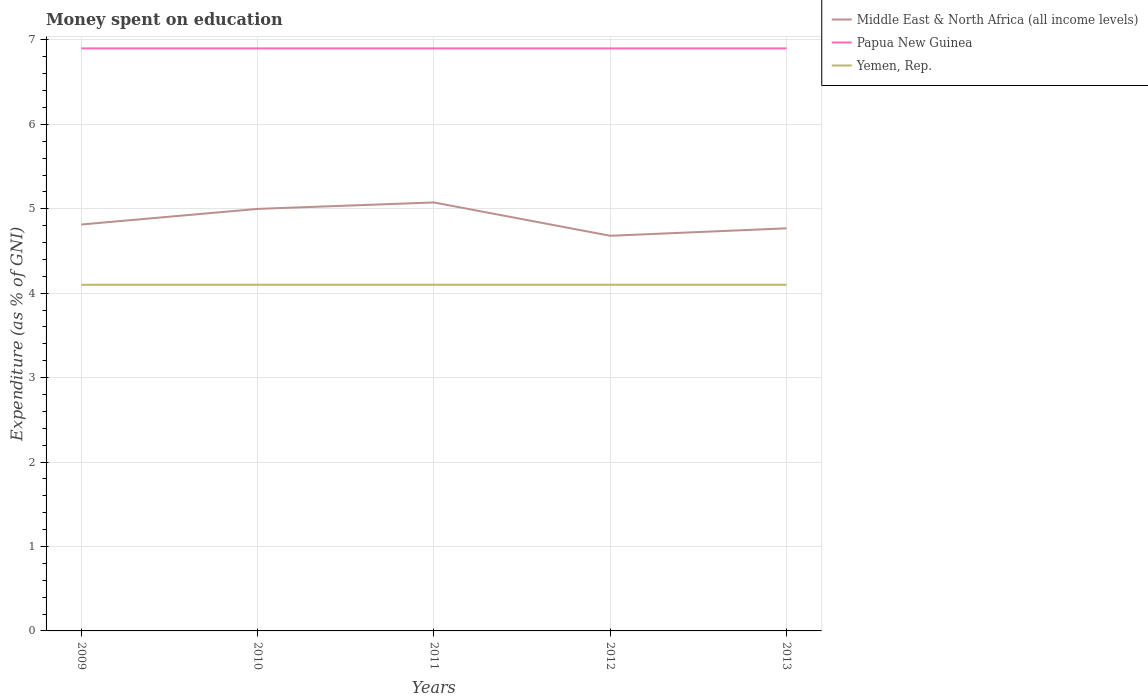How many different coloured lines are there?
Offer a very short reply. 3. In which year was the amount of money spent on education in Papua New Guinea maximum?
Offer a very short reply. 2009. What is the total amount of money spent on education in Papua New Guinea in the graph?
Keep it short and to the point. 0. What is the difference between the highest and the second highest amount of money spent on education in Middle East & North Africa (all income levels)?
Offer a very short reply. 0.39. What is the difference between the highest and the lowest amount of money spent on education in Papua New Guinea?
Offer a very short reply. 0. Is the amount of money spent on education in Middle East & North Africa (all income levels) strictly greater than the amount of money spent on education in Papua New Guinea over the years?
Offer a very short reply. Yes. How many years are there in the graph?
Offer a terse response. 5. What is the difference between two consecutive major ticks on the Y-axis?
Give a very brief answer. 1. Are the values on the major ticks of Y-axis written in scientific E-notation?
Give a very brief answer. No. Does the graph contain any zero values?
Your answer should be compact. No. Does the graph contain grids?
Ensure brevity in your answer.  Yes. Where does the legend appear in the graph?
Keep it short and to the point. Top right. What is the title of the graph?
Make the answer very short. Money spent on education. Does "San Marino" appear as one of the legend labels in the graph?
Offer a terse response. No. What is the label or title of the Y-axis?
Make the answer very short. Expenditure (as % of GNI). What is the Expenditure (as % of GNI) of Middle East & North Africa (all income levels) in 2009?
Give a very brief answer. 4.81. What is the Expenditure (as % of GNI) in Yemen, Rep. in 2009?
Keep it short and to the point. 4.1. What is the Expenditure (as % of GNI) in Middle East & North Africa (all income levels) in 2010?
Keep it short and to the point. 5. What is the Expenditure (as % of GNI) in Papua New Guinea in 2010?
Provide a succinct answer. 6.9. What is the Expenditure (as % of GNI) of Yemen, Rep. in 2010?
Offer a very short reply. 4.1. What is the Expenditure (as % of GNI) in Middle East & North Africa (all income levels) in 2011?
Offer a terse response. 5.08. What is the Expenditure (as % of GNI) in Yemen, Rep. in 2011?
Your answer should be very brief. 4.1. What is the Expenditure (as % of GNI) in Middle East & North Africa (all income levels) in 2012?
Your answer should be compact. 4.68. What is the Expenditure (as % of GNI) in Papua New Guinea in 2012?
Offer a very short reply. 6.9. What is the Expenditure (as % of GNI) in Yemen, Rep. in 2012?
Keep it short and to the point. 4.1. What is the Expenditure (as % of GNI) in Middle East & North Africa (all income levels) in 2013?
Provide a short and direct response. 4.77. What is the Expenditure (as % of GNI) of Papua New Guinea in 2013?
Your answer should be compact. 6.9. Across all years, what is the maximum Expenditure (as % of GNI) of Middle East & North Africa (all income levels)?
Give a very brief answer. 5.08. Across all years, what is the maximum Expenditure (as % of GNI) in Papua New Guinea?
Give a very brief answer. 6.9. Across all years, what is the minimum Expenditure (as % of GNI) in Middle East & North Africa (all income levels)?
Keep it short and to the point. 4.68. What is the total Expenditure (as % of GNI) in Middle East & North Africa (all income levels) in the graph?
Your answer should be very brief. 24.34. What is the total Expenditure (as % of GNI) in Papua New Guinea in the graph?
Your response must be concise. 34.5. What is the difference between the Expenditure (as % of GNI) of Middle East & North Africa (all income levels) in 2009 and that in 2010?
Ensure brevity in your answer.  -0.18. What is the difference between the Expenditure (as % of GNI) of Papua New Guinea in 2009 and that in 2010?
Give a very brief answer. 0. What is the difference between the Expenditure (as % of GNI) of Middle East & North Africa (all income levels) in 2009 and that in 2011?
Offer a very short reply. -0.26. What is the difference between the Expenditure (as % of GNI) of Middle East & North Africa (all income levels) in 2009 and that in 2012?
Your answer should be compact. 0.13. What is the difference between the Expenditure (as % of GNI) in Papua New Guinea in 2009 and that in 2012?
Make the answer very short. 0. What is the difference between the Expenditure (as % of GNI) of Yemen, Rep. in 2009 and that in 2012?
Provide a succinct answer. 0. What is the difference between the Expenditure (as % of GNI) in Middle East & North Africa (all income levels) in 2009 and that in 2013?
Make the answer very short. 0.05. What is the difference between the Expenditure (as % of GNI) in Yemen, Rep. in 2009 and that in 2013?
Your response must be concise. 0. What is the difference between the Expenditure (as % of GNI) of Middle East & North Africa (all income levels) in 2010 and that in 2011?
Your response must be concise. -0.08. What is the difference between the Expenditure (as % of GNI) in Middle East & North Africa (all income levels) in 2010 and that in 2012?
Provide a succinct answer. 0.32. What is the difference between the Expenditure (as % of GNI) of Middle East & North Africa (all income levels) in 2010 and that in 2013?
Offer a very short reply. 0.23. What is the difference between the Expenditure (as % of GNI) of Middle East & North Africa (all income levels) in 2011 and that in 2012?
Give a very brief answer. 0.39. What is the difference between the Expenditure (as % of GNI) of Middle East & North Africa (all income levels) in 2011 and that in 2013?
Your response must be concise. 0.31. What is the difference between the Expenditure (as % of GNI) of Yemen, Rep. in 2011 and that in 2013?
Provide a succinct answer. 0. What is the difference between the Expenditure (as % of GNI) of Middle East & North Africa (all income levels) in 2012 and that in 2013?
Provide a succinct answer. -0.09. What is the difference between the Expenditure (as % of GNI) in Papua New Guinea in 2012 and that in 2013?
Your response must be concise. 0. What is the difference between the Expenditure (as % of GNI) of Yemen, Rep. in 2012 and that in 2013?
Your response must be concise. 0. What is the difference between the Expenditure (as % of GNI) of Middle East & North Africa (all income levels) in 2009 and the Expenditure (as % of GNI) of Papua New Guinea in 2010?
Make the answer very short. -2.09. What is the difference between the Expenditure (as % of GNI) of Middle East & North Africa (all income levels) in 2009 and the Expenditure (as % of GNI) of Yemen, Rep. in 2010?
Your answer should be very brief. 0.71. What is the difference between the Expenditure (as % of GNI) in Papua New Guinea in 2009 and the Expenditure (as % of GNI) in Yemen, Rep. in 2010?
Give a very brief answer. 2.8. What is the difference between the Expenditure (as % of GNI) of Middle East & North Africa (all income levels) in 2009 and the Expenditure (as % of GNI) of Papua New Guinea in 2011?
Provide a succinct answer. -2.09. What is the difference between the Expenditure (as % of GNI) of Middle East & North Africa (all income levels) in 2009 and the Expenditure (as % of GNI) of Yemen, Rep. in 2011?
Your response must be concise. 0.71. What is the difference between the Expenditure (as % of GNI) of Middle East & North Africa (all income levels) in 2009 and the Expenditure (as % of GNI) of Papua New Guinea in 2012?
Your answer should be compact. -2.09. What is the difference between the Expenditure (as % of GNI) of Middle East & North Africa (all income levels) in 2009 and the Expenditure (as % of GNI) of Yemen, Rep. in 2012?
Your answer should be compact. 0.71. What is the difference between the Expenditure (as % of GNI) of Middle East & North Africa (all income levels) in 2009 and the Expenditure (as % of GNI) of Papua New Guinea in 2013?
Your response must be concise. -2.09. What is the difference between the Expenditure (as % of GNI) of Middle East & North Africa (all income levels) in 2009 and the Expenditure (as % of GNI) of Yemen, Rep. in 2013?
Keep it short and to the point. 0.71. What is the difference between the Expenditure (as % of GNI) in Papua New Guinea in 2009 and the Expenditure (as % of GNI) in Yemen, Rep. in 2013?
Offer a terse response. 2.8. What is the difference between the Expenditure (as % of GNI) of Middle East & North Africa (all income levels) in 2010 and the Expenditure (as % of GNI) of Papua New Guinea in 2011?
Provide a succinct answer. -1.9. What is the difference between the Expenditure (as % of GNI) of Middle East & North Africa (all income levels) in 2010 and the Expenditure (as % of GNI) of Yemen, Rep. in 2011?
Offer a very short reply. 0.9. What is the difference between the Expenditure (as % of GNI) in Papua New Guinea in 2010 and the Expenditure (as % of GNI) in Yemen, Rep. in 2011?
Offer a very short reply. 2.8. What is the difference between the Expenditure (as % of GNI) of Middle East & North Africa (all income levels) in 2010 and the Expenditure (as % of GNI) of Papua New Guinea in 2012?
Provide a short and direct response. -1.9. What is the difference between the Expenditure (as % of GNI) in Middle East & North Africa (all income levels) in 2010 and the Expenditure (as % of GNI) in Yemen, Rep. in 2012?
Offer a very short reply. 0.9. What is the difference between the Expenditure (as % of GNI) in Papua New Guinea in 2010 and the Expenditure (as % of GNI) in Yemen, Rep. in 2012?
Your answer should be compact. 2.8. What is the difference between the Expenditure (as % of GNI) in Middle East & North Africa (all income levels) in 2010 and the Expenditure (as % of GNI) in Papua New Guinea in 2013?
Provide a short and direct response. -1.9. What is the difference between the Expenditure (as % of GNI) in Middle East & North Africa (all income levels) in 2010 and the Expenditure (as % of GNI) in Yemen, Rep. in 2013?
Keep it short and to the point. 0.9. What is the difference between the Expenditure (as % of GNI) of Middle East & North Africa (all income levels) in 2011 and the Expenditure (as % of GNI) of Papua New Guinea in 2012?
Provide a short and direct response. -1.82. What is the difference between the Expenditure (as % of GNI) in Middle East & North Africa (all income levels) in 2011 and the Expenditure (as % of GNI) in Yemen, Rep. in 2012?
Offer a terse response. 0.98. What is the difference between the Expenditure (as % of GNI) in Papua New Guinea in 2011 and the Expenditure (as % of GNI) in Yemen, Rep. in 2012?
Your answer should be very brief. 2.8. What is the difference between the Expenditure (as % of GNI) of Middle East & North Africa (all income levels) in 2011 and the Expenditure (as % of GNI) of Papua New Guinea in 2013?
Offer a very short reply. -1.82. What is the difference between the Expenditure (as % of GNI) of Middle East & North Africa (all income levels) in 2011 and the Expenditure (as % of GNI) of Yemen, Rep. in 2013?
Your answer should be very brief. 0.98. What is the difference between the Expenditure (as % of GNI) of Papua New Guinea in 2011 and the Expenditure (as % of GNI) of Yemen, Rep. in 2013?
Give a very brief answer. 2.8. What is the difference between the Expenditure (as % of GNI) of Middle East & North Africa (all income levels) in 2012 and the Expenditure (as % of GNI) of Papua New Guinea in 2013?
Give a very brief answer. -2.22. What is the difference between the Expenditure (as % of GNI) in Middle East & North Africa (all income levels) in 2012 and the Expenditure (as % of GNI) in Yemen, Rep. in 2013?
Provide a short and direct response. 0.58. What is the difference between the Expenditure (as % of GNI) in Papua New Guinea in 2012 and the Expenditure (as % of GNI) in Yemen, Rep. in 2013?
Give a very brief answer. 2.8. What is the average Expenditure (as % of GNI) of Middle East & North Africa (all income levels) per year?
Offer a very short reply. 4.87. What is the average Expenditure (as % of GNI) in Papua New Guinea per year?
Offer a very short reply. 6.9. What is the average Expenditure (as % of GNI) in Yemen, Rep. per year?
Ensure brevity in your answer.  4.1. In the year 2009, what is the difference between the Expenditure (as % of GNI) of Middle East & North Africa (all income levels) and Expenditure (as % of GNI) of Papua New Guinea?
Offer a very short reply. -2.09. In the year 2009, what is the difference between the Expenditure (as % of GNI) in Middle East & North Africa (all income levels) and Expenditure (as % of GNI) in Yemen, Rep.?
Ensure brevity in your answer.  0.71. In the year 2010, what is the difference between the Expenditure (as % of GNI) in Middle East & North Africa (all income levels) and Expenditure (as % of GNI) in Papua New Guinea?
Your response must be concise. -1.9. In the year 2010, what is the difference between the Expenditure (as % of GNI) of Middle East & North Africa (all income levels) and Expenditure (as % of GNI) of Yemen, Rep.?
Make the answer very short. 0.9. In the year 2010, what is the difference between the Expenditure (as % of GNI) of Papua New Guinea and Expenditure (as % of GNI) of Yemen, Rep.?
Provide a succinct answer. 2.8. In the year 2011, what is the difference between the Expenditure (as % of GNI) of Middle East & North Africa (all income levels) and Expenditure (as % of GNI) of Papua New Guinea?
Keep it short and to the point. -1.82. In the year 2011, what is the difference between the Expenditure (as % of GNI) of Middle East & North Africa (all income levels) and Expenditure (as % of GNI) of Yemen, Rep.?
Give a very brief answer. 0.98. In the year 2011, what is the difference between the Expenditure (as % of GNI) of Papua New Guinea and Expenditure (as % of GNI) of Yemen, Rep.?
Make the answer very short. 2.8. In the year 2012, what is the difference between the Expenditure (as % of GNI) of Middle East & North Africa (all income levels) and Expenditure (as % of GNI) of Papua New Guinea?
Your response must be concise. -2.22. In the year 2012, what is the difference between the Expenditure (as % of GNI) in Middle East & North Africa (all income levels) and Expenditure (as % of GNI) in Yemen, Rep.?
Your answer should be compact. 0.58. In the year 2012, what is the difference between the Expenditure (as % of GNI) in Papua New Guinea and Expenditure (as % of GNI) in Yemen, Rep.?
Keep it short and to the point. 2.8. In the year 2013, what is the difference between the Expenditure (as % of GNI) in Middle East & North Africa (all income levels) and Expenditure (as % of GNI) in Papua New Guinea?
Provide a succinct answer. -2.13. In the year 2013, what is the difference between the Expenditure (as % of GNI) in Middle East & North Africa (all income levels) and Expenditure (as % of GNI) in Yemen, Rep.?
Keep it short and to the point. 0.67. In the year 2013, what is the difference between the Expenditure (as % of GNI) in Papua New Guinea and Expenditure (as % of GNI) in Yemen, Rep.?
Your response must be concise. 2.8. What is the ratio of the Expenditure (as % of GNI) in Middle East & North Africa (all income levels) in 2009 to that in 2011?
Give a very brief answer. 0.95. What is the ratio of the Expenditure (as % of GNI) of Papua New Guinea in 2009 to that in 2011?
Offer a very short reply. 1. What is the ratio of the Expenditure (as % of GNI) in Middle East & North Africa (all income levels) in 2009 to that in 2012?
Give a very brief answer. 1.03. What is the ratio of the Expenditure (as % of GNI) of Yemen, Rep. in 2009 to that in 2012?
Keep it short and to the point. 1. What is the ratio of the Expenditure (as % of GNI) of Middle East & North Africa (all income levels) in 2009 to that in 2013?
Your answer should be very brief. 1.01. What is the ratio of the Expenditure (as % of GNI) of Yemen, Rep. in 2009 to that in 2013?
Provide a succinct answer. 1. What is the ratio of the Expenditure (as % of GNI) of Middle East & North Africa (all income levels) in 2010 to that in 2011?
Keep it short and to the point. 0.98. What is the ratio of the Expenditure (as % of GNI) of Yemen, Rep. in 2010 to that in 2011?
Keep it short and to the point. 1. What is the ratio of the Expenditure (as % of GNI) of Middle East & North Africa (all income levels) in 2010 to that in 2012?
Provide a short and direct response. 1.07. What is the ratio of the Expenditure (as % of GNI) in Papua New Guinea in 2010 to that in 2012?
Provide a short and direct response. 1. What is the ratio of the Expenditure (as % of GNI) of Middle East & North Africa (all income levels) in 2010 to that in 2013?
Provide a short and direct response. 1.05. What is the ratio of the Expenditure (as % of GNI) of Papua New Guinea in 2010 to that in 2013?
Offer a terse response. 1. What is the ratio of the Expenditure (as % of GNI) in Middle East & North Africa (all income levels) in 2011 to that in 2012?
Provide a succinct answer. 1.08. What is the ratio of the Expenditure (as % of GNI) in Yemen, Rep. in 2011 to that in 2012?
Provide a succinct answer. 1. What is the ratio of the Expenditure (as % of GNI) of Middle East & North Africa (all income levels) in 2011 to that in 2013?
Provide a succinct answer. 1.06. What is the ratio of the Expenditure (as % of GNI) in Papua New Guinea in 2011 to that in 2013?
Give a very brief answer. 1. What is the ratio of the Expenditure (as % of GNI) in Middle East & North Africa (all income levels) in 2012 to that in 2013?
Offer a very short reply. 0.98. What is the ratio of the Expenditure (as % of GNI) of Papua New Guinea in 2012 to that in 2013?
Provide a short and direct response. 1. What is the ratio of the Expenditure (as % of GNI) of Yemen, Rep. in 2012 to that in 2013?
Give a very brief answer. 1. What is the difference between the highest and the second highest Expenditure (as % of GNI) of Middle East & North Africa (all income levels)?
Your answer should be very brief. 0.08. What is the difference between the highest and the second highest Expenditure (as % of GNI) in Papua New Guinea?
Your answer should be compact. 0. What is the difference between the highest and the second highest Expenditure (as % of GNI) of Yemen, Rep.?
Your answer should be very brief. 0. What is the difference between the highest and the lowest Expenditure (as % of GNI) of Middle East & North Africa (all income levels)?
Your answer should be compact. 0.39. What is the difference between the highest and the lowest Expenditure (as % of GNI) of Papua New Guinea?
Your response must be concise. 0. 